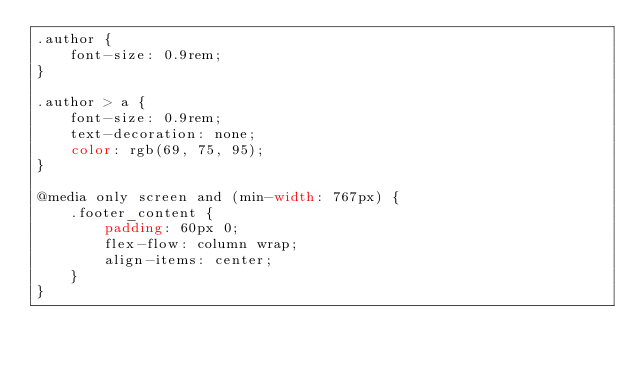Convert code to text. <code><loc_0><loc_0><loc_500><loc_500><_CSS_>.author {
	font-size: 0.9rem;
}

.author > a {
	font-size: 0.9rem;
	text-decoration: none;
	color: rgb(69, 75, 95);
}

@media only screen and (min-width: 767px) {
	.footer_content {
		padding: 60px 0;
		flex-flow: column wrap;
		align-items: center;
	}
}
</code> 